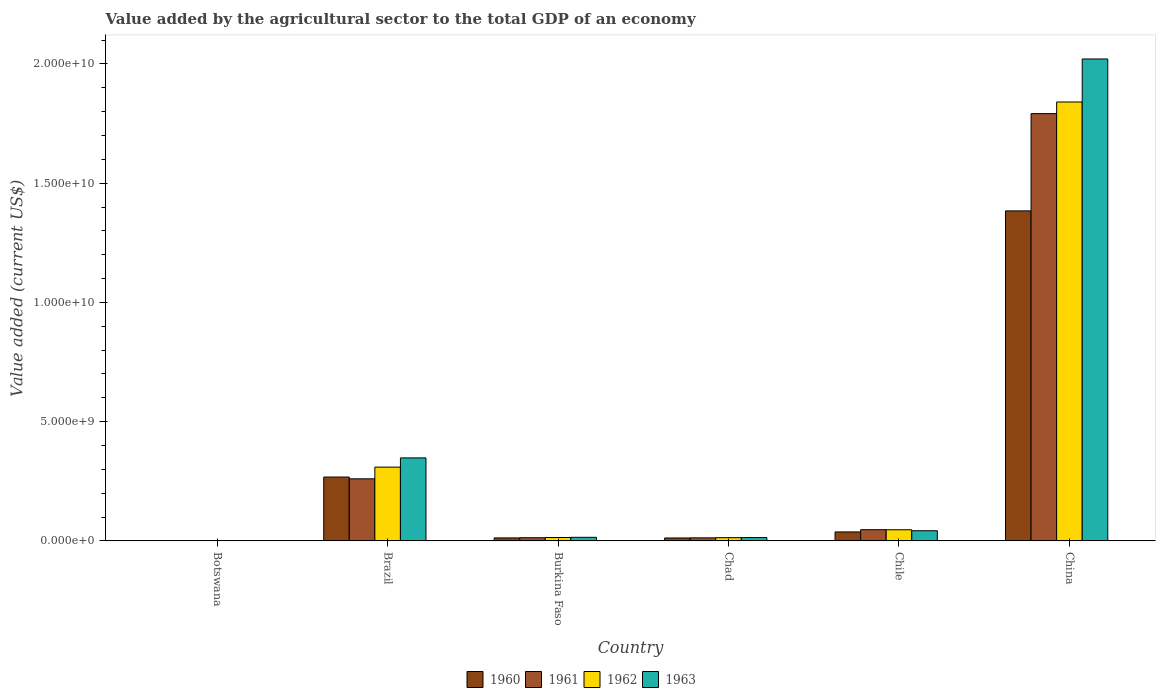How many bars are there on the 2nd tick from the left?
Provide a succinct answer. 4. How many bars are there on the 6th tick from the right?
Provide a succinct answer. 4. What is the label of the 3rd group of bars from the left?
Provide a short and direct response. Burkina Faso. What is the value added by the agricultural sector to the total GDP in 1963 in China?
Your response must be concise. 2.02e+1. Across all countries, what is the maximum value added by the agricultural sector to the total GDP in 1962?
Keep it short and to the point. 1.84e+1. Across all countries, what is the minimum value added by the agricultural sector to the total GDP in 1961?
Make the answer very short. 1.38e+07. In which country was the value added by the agricultural sector to the total GDP in 1962 maximum?
Your answer should be very brief. China. In which country was the value added by the agricultural sector to the total GDP in 1961 minimum?
Give a very brief answer. Botswana. What is the total value added by the agricultural sector to the total GDP in 1963 in the graph?
Provide a succinct answer. 2.44e+1. What is the difference between the value added by the agricultural sector to the total GDP in 1960 in Botswana and that in Burkina Faso?
Give a very brief answer. -1.14e+08. What is the difference between the value added by the agricultural sector to the total GDP in 1962 in Burkina Faso and the value added by the agricultural sector to the total GDP in 1963 in Chad?
Make the answer very short. 2.33e+06. What is the average value added by the agricultural sector to the total GDP in 1961 per country?
Give a very brief answer. 3.55e+09. What is the difference between the value added by the agricultural sector to the total GDP of/in 1962 and value added by the agricultural sector to the total GDP of/in 1960 in Brazil?
Offer a terse response. 4.16e+08. What is the ratio of the value added by the agricultural sector to the total GDP in 1963 in Botswana to that in China?
Your answer should be compact. 0. Is the value added by the agricultural sector to the total GDP in 1962 in Botswana less than that in Chad?
Your answer should be compact. Yes. What is the difference between the highest and the second highest value added by the agricultural sector to the total GDP in 1963?
Your answer should be very brief. 1.98e+1. What is the difference between the highest and the lowest value added by the agricultural sector to the total GDP in 1963?
Provide a succinct answer. 2.02e+1. Is it the case that in every country, the sum of the value added by the agricultural sector to the total GDP in 1962 and value added by the agricultural sector to the total GDP in 1960 is greater than the sum of value added by the agricultural sector to the total GDP in 1963 and value added by the agricultural sector to the total GDP in 1961?
Provide a succinct answer. No. What does the 1st bar from the right in Botswana represents?
Your response must be concise. 1963. How many bars are there?
Give a very brief answer. 24. How many countries are there in the graph?
Provide a succinct answer. 6. What is the difference between two consecutive major ticks on the Y-axis?
Make the answer very short. 5.00e+09. Does the graph contain grids?
Provide a succinct answer. No. Where does the legend appear in the graph?
Your response must be concise. Bottom center. What is the title of the graph?
Keep it short and to the point. Value added by the agricultural sector to the total GDP of an economy. Does "1971" appear as one of the legend labels in the graph?
Give a very brief answer. No. What is the label or title of the Y-axis?
Offer a very short reply. Value added (current US$). What is the Value added (current US$) of 1960 in Botswana?
Your answer should be very brief. 1.31e+07. What is the Value added (current US$) in 1961 in Botswana?
Keep it short and to the point. 1.38e+07. What is the Value added (current US$) of 1962 in Botswana?
Give a very brief answer. 1.45e+07. What is the Value added (current US$) in 1963 in Botswana?
Provide a succinct answer. 1.51e+07. What is the Value added (current US$) of 1960 in Brazil?
Your answer should be very brief. 2.68e+09. What is the Value added (current US$) in 1961 in Brazil?
Offer a very short reply. 2.60e+09. What is the Value added (current US$) in 1962 in Brazil?
Offer a very short reply. 3.10e+09. What is the Value added (current US$) in 1963 in Brazil?
Your answer should be compact. 3.48e+09. What is the Value added (current US$) in 1960 in Burkina Faso?
Provide a short and direct response. 1.27e+08. What is the Value added (current US$) in 1961 in Burkina Faso?
Offer a terse response. 1.34e+08. What is the Value added (current US$) of 1962 in Burkina Faso?
Your response must be concise. 1.44e+08. What is the Value added (current US$) in 1963 in Burkina Faso?
Provide a short and direct response. 1.52e+08. What is the Value added (current US$) in 1960 in Chad?
Offer a very short reply. 1.25e+08. What is the Value added (current US$) in 1961 in Chad?
Keep it short and to the point. 1.29e+08. What is the Value added (current US$) in 1962 in Chad?
Offer a terse response. 1.38e+08. What is the Value added (current US$) of 1963 in Chad?
Provide a succinct answer. 1.41e+08. What is the Value added (current US$) of 1960 in Chile?
Give a very brief answer. 3.78e+08. What is the Value added (current US$) of 1961 in Chile?
Provide a short and direct response. 4.72e+08. What is the Value added (current US$) in 1962 in Chile?
Your response must be concise. 4.69e+08. What is the Value added (current US$) of 1963 in Chile?
Give a very brief answer. 4.28e+08. What is the Value added (current US$) of 1960 in China?
Your response must be concise. 1.38e+1. What is the Value added (current US$) of 1961 in China?
Your answer should be compact. 1.79e+1. What is the Value added (current US$) in 1962 in China?
Make the answer very short. 1.84e+1. What is the Value added (current US$) of 1963 in China?
Make the answer very short. 2.02e+1. Across all countries, what is the maximum Value added (current US$) of 1960?
Your response must be concise. 1.38e+1. Across all countries, what is the maximum Value added (current US$) of 1961?
Provide a short and direct response. 1.79e+1. Across all countries, what is the maximum Value added (current US$) of 1962?
Keep it short and to the point. 1.84e+1. Across all countries, what is the maximum Value added (current US$) of 1963?
Your answer should be very brief. 2.02e+1. Across all countries, what is the minimum Value added (current US$) in 1960?
Make the answer very short. 1.31e+07. Across all countries, what is the minimum Value added (current US$) in 1961?
Give a very brief answer. 1.38e+07. Across all countries, what is the minimum Value added (current US$) in 1962?
Make the answer very short. 1.45e+07. Across all countries, what is the minimum Value added (current US$) of 1963?
Your response must be concise. 1.51e+07. What is the total Value added (current US$) in 1960 in the graph?
Ensure brevity in your answer.  1.72e+1. What is the total Value added (current US$) in 1961 in the graph?
Offer a very short reply. 2.13e+1. What is the total Value added (current US$) of 1962 in the graph?
Provide a succinct answer. 2.23e+1. What is the total Value added (current US$) in 1963 in the graph?
Your response must be concise. 2.44e+1. What is the difference between the Value added (current US$) of 1960 in Botswana and that in Brazil?
Your answer should be compact. -2.67e+09. What is the difference between the Value added (current US$) of 1961 in Botswana and that in Brazil?
Offer a terse response. -2.59e+09. What is the difference between the Value added (current US$) of 1962 in Botswana and that in Brazil?
Ensure brevity in your answer.  -3.08e+09. What is the difference between the Value added (current US$) in 1963 in Botswana and that in Brazil?
Your answer should be compact. -3.47e+09. What is the difference between the Value added (current US$) of 1960 in Botswana and that in Burkina Faso?
Offer a very short reply. -1.14e+08. What is the difference between the Value added (current US$) in 1961 in Botswana and that in Burkina Faso?
Your response must be concise. -1.20e+08. What is the difference between the Value added (current US$) in 1962 in Botswana and that in Burkina Faso?
Your response must be concise. -1.29e+08. What is the difference between the Value added (current US$) in 1963 in Botswana and that in Burkina Faso?
Provide a short and direct response. -1.37e+08. What is the difference between the Value added (current US$) of 1960 in Botswana and that in Chad?
Give a very brief answer. -1.11e+08. What is the difference between the Value added (current US$) in 1961 in Botswana and that in Chad?
Offer a terse response. -1.16e+08. What is the difference between the Value added (current US$) in 1962 in Botswana and that in Chad?
Make the answer very short. -1.23e+08. What is the difference between the Value added (current US$) in 1963 in Botswana and that in Chad?
Give a very brief answer. -1.26e+08. What is the difference between the Value added (current US$) of 1960 in Botswana and that in Chile?
Offer a very short reply. -3.65e+08. What is the difference between the Value added (current US$) in 1961 in Botswana and that in Chile?
Provide a succinct answer. -4.58e+08. What is the difference between the Value added (current US$) in 1962 in Botswana and that in Chile?
Offer a terse response. -4.54e+08. What is the difference between the Value added (current US$) in 1963 in Botswana and that in Chile?
Your answer should be compact. -4.13e+08. What is the difference between the Value added (current US$) in 1960 in Botswana and that in China?
Offer a terse response. -1.38e+1. What is the difference between the Value added (current US$) in 1961 in Botswana and that in China?
Make the answer very short. -1.79e+1. What is the difference between the Value added (current US$) of 1962 in Botswana and that in China?
Offer a very short reply. -1.84e+1. What is the difference between the Value added (current US$) of 1963 in Botswana and that in China?
Provide a short and direct response. -2.02e+1. What is the difference between the Value added (current US$) of 1960 in Brazil and that in Burkina Faso?
Make the answer very short. 2.55e+09. What is the difference between the Value added (current US$) in 1961 in Brazil and that in Burkina Faso?
Provide a short and direct response. 2.47e+09. What is the difference between the Value added (current US$) in 1962 in Brazil and that in Burkina Faso?
Provide a short and direct response. 2.95e+09. What is the difference between the Value added (current US$) in 1963 in Brazil and that in Burkina Faso?
Your response must be concise. 3.33e+09. What is the difference between the Value added (current US$) of 1960 in Brazil and that in Chad?
Ensure brevity in your answer.  2.55e+09. What is the difference between the Value added (current US$) of 1961 in Brazil and that in Chad?
Make the answer very short. 2.48e+09. What is the difference between the Value added (current US$) of 1962 in Brazil and that in Chad?
Offer a very short reply. 2.96e+09. What is the difference between the Value added (current US$) of 1963 in Brazil and that in Chad?
Ensure brevity in your answer.  3.34e+09. What is the difference between the Value added (current US$) of 1960 in Brazil and that in Chile?
Ensure brevity in your answer.  2.30e+09. What is the difference between the Value added (current US$) in 1961 in Brazil and that in Chile?
Provide a succinct answer. 2.13e+09. What is the difference between the Value added (current US$) in 1962 in Brazil and that in Chile?
Provide a short and direct response. 2.63e+09. What is the difference between the Value added (current US$) in 1963 in Brazil and that in Chile?
Your answer should be very brief. 3.05e+09. What is the difference between the Value added (current US$) of 1960 in Brazil and that in China?
Provide a short and direct response. -1.12e+1. What is the difference between the Value added (current US$) of 1961 in Brazil and that in China?
Offer a terse response. -1.53e+1. What is the difference between the Value added (current US$) of 1962 in Brazil and that in China?
Keep it short and to the point. -1.53e+1. What is the difference between the Value added (current US$) of 1963 in Brazil and that in China?
Provide a succinct answer. -1.67e+1. What is the difference between the Value added (current US$) in 1960 in Burkina Faso and that in Chad?
Your response must be concise. 2.61e+06. What is the difference between the Value added (current US$) of 1961 in Burkina Faso and that in Chad?
Ensure brevity in your answer.  4.79e+06. What is the difference between the Value added (current US$) in 1962 in Burkina Faso and that in Chad?
Ensure brevity in your answer.  6.10e+06. What is the difference between the Value added (current US$) in 1963 in Burkina Faso and that in Chad?
Ensure brevity in your answer.  1.03e+07. What is the difference between the Value added (current US$) of 1960 in Burkina Faso and that in Chile?
Your answer should be compact. -2.51e+08. What is the difference between the Value added (current US$) in 1961 in Burkina Faso and that in Chile?
Your answer should be compact. -3.38e+08. What is the difference between the Value added (current US$) in 1962 in Burkina Faso and that in Chile?
Ensure brevity in your answer.  -3.25e+08. What is the difference between the Value added (current US$) of 1963 in Burkina Faso and that in Chile?
Provide a short and direct response. -2.76e+08. What is the difference between the Value added (current US$) of 1960 in Burkina Faso and that in China?
Give a very brief answer. -1.37e+1. What is the difference between the Value added (current US$) of 1961 in Burkina Faso and that in China?
Offer a very short reply. -1.78e+1. What is the difference between the Value added (current US$) of 1962 in Burkina Faso and that in China?
Offer a very short reply. -1.83e+1. What is the difference between the Value added (current US$) in 1963 in Burkina Faso and that in China?
Provide a succinct answer. -2.01e+1. What is the difference between the Value added (current US$) in 1960 in Chad and that in Chile?
Your answer should be compact. -2.54e+08. What is the difference between the Value added (current US$) of 1961 in Chad and that in Chile?
Provide a short and direct response. -3.43e+08. What is the difference between the Value added (current US$) of 1962 in Chad and that in Chile?
Your answer should be compact. -3.31e+08. What is the difference between the Value added (current US$) in 1963 in Chad and that in Chile?
Your answer should be compact. -2.87e+08. What is the difference between the Value added (current US$) in 1960 in Chad and that in China?
Offer a terse response. -1.37e+1. What is the difference between the Value added (current US$) in 1961 in Chad and that in China?
Your answer should be very brief. -1.78e+1. What is the difference between the Value added (current US$) of 1962 in Chad and that in China?
Your answer should be compact. -1.83e+1. What is the difference between the Value added (current US$) of 1963 in Chad and that in China?
Your answer should be compact. -2.01e+1. What is the difference between the Value added (current US$) of 1960 in Chile and that in China?
Make the answer very short. -1.35e+1. What is the difference between the Value added (current US$) of 1961 in Chile and that in China?
Offer a terse response. -1.74e+1. What is the difference between the Value added (current US$) in 1962 in Chile and that in China?
Offer a very short reply. -1.79e+1. What is the difference between the Value added (current US$) in 1963 in Chile and that in China?
Your answer should be compact. -1.98e+1. What is the difference between the Value added (current US$) of 1960 in Botswana and the Value added (current US$) of 1961 in Brazil?
Ensure brevity in your answer.  -2.59e+09. What is the difference between the Value added (current US$) of 1960 in Botswana and the Value added (current US$) of 1962 in Brazil?
Offer a very short reply. -3.08e+09. What is the difference between the Value added (current US$) of 1960 in Botswana and the Value added (current US$) of 1963 in Brazil?
Offer a terse response. -3.47e+09. What is the difference between the Value added (current US$) of 1961 in Botswana and the Value added (current US$) of 1962 in Brazil?
Your answer should be compact. -3.08e+09. What is the difference between the Value added (current US$) of 1961 in Botswana and the Value added (current US$) of 1963 in Brazil?
Give a very brief answer. -3.47e+09. What is the difference between the Value added (current US$) in 1962 in Botswana and the Value added (current US$) in 1963 in Brazil?
Provide a succinct answer. -3.47e+09. What is the difference between the Value added (current US$) in 1960 in Botswana and the Value added (current US$) in 1961 in Burkina Faso?
Ensure brevity in your answer.  -1.21e+08. What is the difference between the Value added (current US$) of 1960 in Botswana and the Value added (current US$) of 1962 in Burkina Faso?
Provide a short and direct response. -1.31e+08. What is the difference between the Value added (current US$) of 1960 in Botswana and the Value added (current US$) of 1963 in Burkina Faso?
Provide a succinct answer. -1.39e+08. What is the difference between the Value added (current US$) in 1961 in Botswana and the Value added (current US$) in 1962 in Burkina Faso?
Provide a succinct answer. -1.30e+08. What is the difference between the Value added (current US$) of 1961 in Botswana and the Value added (current US$) of 1963 in Burkina Faso?
Offer a very short reply. -1.38e+08. What is the difference between the Value added (current US$) of 1962 in Botswana and the Value added (current US$) of 1963 in Burkina Faso?
Your response must be concise. -1.37e+08. What is the difference between the Value added (current US$) in 1960 in Botswana and the Value added (current US$) in 1961 in Chad?
Make the answer very short. -1.16e+08. What is the difference between the Value added (current US$) of 1960 in Botswana and the Value added (current US$) of 1962 in Chad?
Offer a very short reply. -1.24e+08. What is the difference between the Value added (current US$) in 1960 in Botswana and the Value added (current US$) in 1963 in Chad?
Offer a very short reply. -1.28e+08. What is the difference between the Value added (current US$) of 1961 in Botswana and the Value added (current US$) of 1962 in Chad?
Offer a terse response. -1.24e+08. What is the difference between the Value added (current US$) in 1961 in Botswana and the Value added (current US$) in 1963 in Chad?
Your response must be concise. -1.28e+08. What is the difference between the Value added (current US$) of 1962 in Botswana and the Value added (current US$) of 1963 in Chad?
Make the answer very short. -1.27e+08. What is the difference between the Value added (current US$) of 1960 in Botswana and the Value added (current US$) of 1961 in Chile?
Your response must be concise. -4.59e+08. What is the difference between the Value added (current US$) in 1960 in Botswana and the Value added (current US$) in 1962 in Chile?
Offer a very short reply. -4.55e+08. What is the difference between the Value added (current US$) of 1960 in Botswana and the Value added (current US$) of 1963 in Chile?
Offer a terse response. -4.15e+08. What is the difference between the Value added (current US$) of 1961 in Botswana and the Value added (current US$) of 1962 in Chile?
Provide a succinct answer. -4.55e+08. What is the difference between the Value added (current US$) of 1961 in Botswana and the Value added (current US$) of 1963 in Chile?
Your answer should be very brief. -4.14e+08. What is the difference between the Value added (current US$) in 1962 in Botswana and the Value added (current US$) in 1963 in Chile?
Make the answer very short. -4.13e+08. What is the difference between the Value added (current US$) in 1960 in Botswana and the Value added (current US$) in 1961 in China?
Provide a short and direct response. -1.79e+1. What is the difference between the Value added (current US$) of 1960 in Botswana and the Value added (current US$) of 1962 in China?
Offer a terse response. -1.84e+1. What is the difference between the Value added (current US$) in 1960 in Botswana and the Value added (current US$) in 1963 in China?
Make the answer very short. -2.02e+1. What is the difference between the Value added (current US$) of 1961 in Botswana and the Value added (current US$) of 1962 in China?
Offer a terse response. -1.84e+1. What is the difference between the Value added (current US$) of 1961 in Botswana and the Value added (current US$) of 1963 in China?
Provide a short and direct response. -2.02e+1. What is the difference between the Value added (current US$) in 1962 in Botswana and the Value added (current US$) in 1963 in China?
Your answer should be very brief. -2.02e+1. What is the difference between the Value added (current US$) in 1960 in Brazil and the Value added (current US$) in 1961 in Burkina Faso?
Offer a very short reply. 2.55e+09. What is the difference between the Value added (current US$) of 1960 in Brazil and the Value added (current US$) of 1962 in Burkina Faso?
Give a very brief answer. 2.54e+09. What is the difference between the Value added (current US$) of 1960 in Brazil and the Value added (current US$) of 1963 in Burkina Faso?
Give a very brief answer. 2.53e+09. What is the difference between the Value added (current US$) of 1961 in Brazil and the Value added (current US$) of 1962 in Burkina Faso?
Make the answer very short. 2.46e+09. What is the difference between the Value added (current US$) of 1961 in Brazil and the Value added (current US$) of 1963 in Burkina Faso?
Provide a succinct answer. 2.45e+09. What is the difference between the Value added (current US$) of 1962 in Brazil and the Value added (current US$) of 1963 in Burkina Faso?
Make the answer very short. 2.94e+09. What is the difference between the Value added (current US$) of 1960 in Brazil and the Value added (current US$) of 1961 in Chad?
Offer a terse response. 2.55e+09. What is the difference between the Value added (current US$) of 1960 in Brazil and the Value added (current US$) of 1962 in Chad?
Give a very brief answer. 2.54e+09. What is the difference between the Value added (current US$) of 1960 in Brazil and the Value added (current US$) of 1963 in Chad?
Ensure brevity in your answer.  2.54e+09. What is the difference between the Value added (current US$) of 1961 in Brazil and the Value added (current US$) of 1962 in Chad?
Offer a very short reply. 2.47e+09. What is the difference between the Value added (current US$) in 1961 in Brazil and the Value added (current US$) in 1963 in Chad?
Make the answer very short. 2.46e+09. What is the difference between the Value added (current US$) in 1962 in Brazil and the Value added (current US$) in 1963 in Chad?
Your response must be concise. 2.95e+09. What is the difference between the Value added (current US$) in 1960 in Brazil and the Value added (current US$) in 1961 in Chile?
Your answer should be very brief. 2.21e+09. What is the difference between the Value added (current US$) in 1960 in Brazil and the Value added (current US$) in 1962 in Chile?
Make the answer very short. 2.21e+09. What is the difference between the Value added (current US$) in 1960 in Brazil and the Value added (current US$) in 1963 in Chile?
Give a very brief answer. 2.25e+09. What is the difference between the Value added (current US$) in 1961 in Brazil and the Value added (current US$) in 1962 in Chile?
Your answer should be very brief. 2.14e+09. What is the difference between the Value added (current US$) in 1961 in Brazil and the Value added (current US$) in 1963 in Chile?
Offer a very short reply. 2.18e+09. What is the difference between the Value added (current US$) of 1962 in Brazil and the Value added (current US$) of 1963 in Chile?
Your response must be concise. 2.67e+09. What is the difference between the Value added (current US$) of 1960 in Brazil and the Value added (current US$) of 1961 in China?
Make the answer very short. -1.52e+1. What is the difference between the Value added (current US$) of 1960 in Brazil and the Value added (current US$) of 1962 in China?
Your response must be concise. -1.57e+1. What is the difference between the Value added (current US$) in 1960 in Brazil and the Value added (current US$) in 1963 in China?
Your answer should be very brief. -1.75e+1. What is the difference between the Value added (current US$) of 1961 in Brazil and the Value added (current US$) of 1962 in China?
Your response must be concise. -1.58e+1. What is the difference between the Value added (current US$) of 1961 in Brazil and the Value added (current US$) of 1963 in China?
Give a very brief answer. -1.76e+1. What is the difference between the Value added (current US$) of 1962 in Brazil and the Value added (current US$) of 1963 in China?
Offer a terse response. -1.71e+1. What is the difference between the Value added (current US$) in 1960 in Burkina Faso and the Value added (current US$) in 1961 in Chad?
Your answer should be very brief. -2.21e+06. What is the difference between the Value added (current US$) in 1960 in Burkina Faso and the Value added (current US$) in 1962 in Chad?
Provide a succinct answer. -1.04e+07. What is the difference between the Value added (current US$) of 1960 in Burkina Faso and the Value added (current US$) of 1963 in Chad?
Your response must be concise. -1.42e+07. What is the difference between the Value added (current US$) in 1961 in Burkina Faso and the Value added (current US$) in 1962 in Chad?
Make the answer very short. -3.43e+06. What is the difference between the Value added (current US$) of 1961 in Burkina Faso and the Value added (current US$) of 1963 in Chad?
Give a very brief answer. -7.20e+06. What is the difference between the Value added (current US$) in 1962 in Burkina Faso and the Value added (current US$) in 1963 in Chad?
Your response must be concise. 2.33e+06. What is the difference between the Value added (current US$) in 1960 in Burkina Faso and the Value added (current US$) in 1961 in Chile?
Offer a terse response. -3.45e+08. What is the difference between the Value added (current US$) in 1960 in Burkina Faso and the Value added (current US$) in 1962 in Chile?
Offer a terse response. -3.41e+08. What is the difference between the Value added (current US$) in 1960 in Burkina Faso and the Value added (current US$) in 1963 in Chile?
Ensure brevity in your answer.  -3.01e+08. What is the difference between the Value added (current US$) in 1961 in Burkina Faso and the Value added (current US$) in 1962 in Chile?
Your response must be concise. -3.34e+08. What is the difference between the Value added (current US$) of 1961 in Burkina Faso and the Value added (current US$) of 1963 in Chile?
Your answer should be compact. -2.94e+08. What is the difference between the Value added (current US$) in 1962 in Burkina Faso and the Value added (current US$) in 1963 in Chile?
Offer a terse response. -2.84e+08. What is the difference between the Value added (current US$) in 1960 in Burkina Faso and the Value added (current US$) in 1961 in China?
Offer a very short reply. -1.78e+1. What is the difference between the Value added (current US$) of 1960 in Burkina Faso and the Value added (current US$) of 1962 in China?
Keep it short and to the point. -1.83e+1. What is the difference between the Value added (current US$) in 1960 in Burkina Faso and the Value added (current US$) in 1963 in China?
Provide a succinct answer. -2.01e+1. What is the difference between the Value added (current US$) of 1961 in Burkina Faso and the Value added (current US$) of 1962 in China?
Your answer should be compact. -1.83e+1. What is the difference between the Value added (current US$) of 1961 in Burkina Faso and the Value added (current US$) of 1963 in China?
Provide a short and direct response. -2.01e+1. What is the difference between the Value added (current US$) of 1962 in Burkina Faso and the Value added (current US$) of 1963 in China?
Give a very brief answer. -2.01e+1. What is the difference between the Value added (current US$) of 1960 in Chad and the Value added (current US$) of 1961 in Chile?
Provide a short and direct response. -3.48e+08. What is the difference between the Value added (current US$) in 1960 in Chad and the Value added (current US$) in 1962 in Chile?
Keep it short and to the point. -3.44e+08. What is the difference between the Value added (current US$) in 1960 in Chad and the Value added (current US$) in 1963 in Chile?
Your response must be concise. -3.03e+08. What is the difference between the Value added (current US$) in 1961 in Chad and the Value added (current US$) in 1962 in Chile?
Ensure brevity in your answer.  -3.39e+08. What is the difference between the Value added (current US$) of 1961 in Chad and the Value added (current US$) of 1963 in Chile?
Your response must be concise. -2.99e+08. What is the difference between the Value added (current US$) in 1962 in Chad and the Value added (current US$) in 1963 in Chile?
Provide a succinct answer. -2.90e+08. What is the difference between the Value added (current US$) of 1960 in Chad and the Value added (current US$) of 1961 in China?
Make the answer very short. -1.78e+1. What is the difference between the Value added (current US$) of 1960 in Chad and the Value added (current US$) of 1962 in China?
Your response must be concise. -1.83e+1. What is the difference between the Value added (current US$) in 1960 in Chad and the Value added (current US$) in 1963 in China?
Give a very brief answer. -2.01e+1. What is the difference between the Value added (current US$) of 1961 in Chad and the Value added (current US$) of 1962 in China?
Provide a short and direct response. -1.83e+1. What is the difference between the Value added (current US$) in 1961 in Chad and the Value added (current US$) in 1963 in China?
Provide a succinct answer. -2.01e+1. What is the difference between the Value added (current US$) in 1962 in Chad and the Value added (current US$) in 1963 in China?
Offer a very short reply. -2.01e+1. What is the difference between the Value added (current US$) in 1960 in Chile and the Value added (current US$) in 1961 in China?
Your answer should be compact. -1.75e+1. What is the difference between the Value added (current US$) of 1960 in Chile and the Value added (current US$) of 1962 in China?
Make the answer very short. -1.80e+1. What is the difference between the Value added (current US$) of 1960 in Chile and the Value added (current US$) of 1963 in China?
Your response must be concise. -1.98e+1. What is the difference between the Value added (current US$) of 1961 in Chile and the Value added (current US$) of 1962 in China?
Keep it short and to the point. -1.79e+1. What is the difference between the Value added (current US$) of 1961 in Chile and the Value added (current US$) of 1963 in China?
Offer a very short reply. -1.97e+1. What is the difference between the Value added (current US$) of 1962 in Chile and the Value added (current US$) of 1963 in China?
Give a very brief answer. -1.97e+1. What is the average Value added (current US$) of 1960 per country?
Keep it short and to the point. 2.86e+09. What is the average Value added (current US$) in 1961 per country?
Your response must be concise. 3.55e+09. What is the average Value added (current US$) in 1962 per country?
Offer a terse response. 3.71e+09. What is the average Value added (current US$) in 1963 per country?
Your response must be concise. 4.07e+09. What is the difference between the Value added (current US$) of 1960 and Value added (current US$) of 1961 in Botswana?
Ensure brevity in your answer.  -6.50e+05. What is the difference between the Value added (current US$) of 1960 and Value added (current US$) of 1962 in Botswana?
Offer a terse response. -1.35e+06. What is the difference between the Value added (current US$) in 1960 and Value added (current US$) in 1963 in Botswana?
Give a very brief answer. -1.99e+06. What is the difference between the Value added (current US$) in 1961 and Value added (current US$) in 1962 in Botswana?
Keep it short and to the point. -7.04e+05. What is the difference between the Value added (current US$) in 1961 and Value added (current US$) in 1963 in Botswana?
Keep it short and to the point. -1.34e+06. What is the difference between the Value added (current US$) in 1962 and Value added (current US$) in 1963 in Botswana?
Ensure brevity in your answer.  -6.34e+05. What is the difference between the Value added (current US$) in 1960 and Value added (current US$) in 1961 in Brazil?
Offer a very short reply. 7.45e+07. What is the difference between the Value added (current US$) in 1960 and Value added (current US$) in 1962 in Brazil?
Offer a terse response. -4.16e+08. What is the difference between the Value added (current US$) of 1960 and Value added (current US$) of 1963 in Brazil?
Make the answer very short. -8.03e+08. What is the difference between the Value added (current US$) in 1961 and Value added (current US$) in 1962 in Brazil?
Ensure brevity in your answer.  -4.91e+08. What is the difference between the Value added (current US$) in 1961 and Value added (current US$) in 1963 in Brazil?
Make the answer very short. -8.77e+08. What is the difference between the Value added (current US$) of 1962 and Value added (current US$) of 1963 in Brazil?
Make the answer very short. -3.87e+08. What is the difference between the Value added (current US$) in 1960 and Value added (current US$) in 1961 in Burkina Faso?
Your answer should be compact. -7.00e+06. What is the difference between the Value added (current US$) in 1960 and Value added (current US$) in 1962 in Burkina Faso?
Your answer should be very brief. -1.65e+07. What is the difference between the Value added (current US$) of 1960 and Value added (current US$) of 1963 in Burkina Faso?
Provide a succinct answer. -2.45e+07. What is the difference between the Value added (current US$) in 1961 and Value added (current US$) in 1962 in Burkina Faso?
Your answer should be very brief. -9.53e+06. What is the difference between the Value added (current US$) in 1961 and Value added (current US$) in 1963 in Burkina Faso?
Your answer should be very brief. -1.75e+07. What is the difference between the Value added (current US$) in 1962 and Value added (current US$) in 1963 in Burkina Faso?
Your answer should be compact. -7.98e+06. What is the difference between the Value added (current US$) of 1960 and Value added (current US$) of 1961 in Chad?
Keep it short and to the point. -4.82e+06. What is the difference between the Value added (current US$) in 1960 and Value added (current US$) in 1962 in Chad?
Keep it short and to the point. -1.30e+07. What is the difference between the Value added (current US$) in 1960 and Value added (current US$) in 1963 in Chad?
Ensure brevity in your answer.  -1.68e+07. What is the difference between the Value added (current US$) of 1961 and Value added (current US$) of 1962 in Chad?
Provide a succinct answer. -8.22e+06. What is the difference between the Value added (current US$) of 1961 and Value added (current US$) of 1963 in Chad?
Offer a very short reply. -1.20e+07. What is the difference between the Value added (current US$) of 1962 and Value added (current US$) of 1963 in Chad?
Provide a succinct answer. -3.78e+06. What is the difference between the Value added (current US$) of 1960 and Value added (current US$) of 1961 in Chile?
Offer a terse response. -9.41e+07. What is the difference between the Value added (current US$) of 1960 and Value added (current US$) of 1962 in Chile?
Your response must be concise. -9.05e+07. What is the difference between the Value added (current US$) in 1960 and Value added (current US$) in 1963 in Chile?
Provide a short and direct response. -4.98e+07. What is the difference between the Value added (current US$) of 1961 and Value added (current US$) of 1962 in Chile?
Make the answer very short. 3.57e+06. What is the difference between the Value added (current US$) of 1961 and Value added (current US$) of 1963 in Chile?
Offer a very short reply. 4.42e+07. What is the difference between the Value added (current US$) in 1962 and Value added (current US$) in 1963 in Chile?
Ensure brevity in your answer.  4.07e+07. What is the difference between the Value added (current US$) of 1960 and Value added (current US$) of 1961 in China?
Your answer should be very brief. -4.08e+09. What is the difference between the Value added (current US$) of 1960 and Value added (current US$) of 1962 in China?
Your response must be concise. -4.57e+09. What is the difference between the Value added (current US$) of 1960 and Value added (current US$) of 1963 in China?
Your answer should be very brief. -6.37e+09. What is the difference between the Value added (current US$) in 1961 and Value added (current US$) in 1962 in China?
Provide a short and direct response. -4.87e+08. What is the difference between the Value added (current US$) in 1961 and Value added (current US$) in 1963 in China?
Provide a succinct answer. -2.29e+09. What is the difference between the Value added (current US$) in 1962 and Value added (current US$) in 1963 in China?
Your answer should be compact. -1.80e+09. What is the ratio of the Value added (current US$) of 1960 in Botswana to that in Brazil?
Ensure brevity in your answer.  0. What is the ratio of the Value added (current US$) in 1961 in Botswana to that in Brazil?
Offer a very short reply. 0.01. What is the ratio of the Value added (current US$) of 1962 in Botswana to that in Brazil?
Offer a very short reply. 0. What is the ratio of the Value added (current US$) in 1963 in Botswana to that in Brazil?
Offer a very short reply. 0. What is the ratio of the Value added (current US$) of 1960 in Botswana to that in Burkina Faso?
Make the answer very short. 0.1. What is the ratio of the Value added (current US$) of 1961 in Botswana to that in Burkina Faso?
Your answer should be compact. 0.1. What is the ratio of the Value added (current US$) in 1962 in Botswana to that in Burkina Faso?
Ensure brevity in your answer.  0.1. What is the ratio of the Value added (current US$) in 1963 in Botswana to that in Burkina Faso?
Your answer should be very brief. 0.1. What is the ratio of the Value added (current US$) of 1960 in Botswana to that in Chad?
Offer a terse response. 0.11. What is the ratio of the Value added (current US$) in 1961 in Botswana to that in Chad?
Offer a terse response. 0.11. What is the ratio of the Value added (current US$) in 1962 in Botswana to that in Chad?
Keep it short and to the point. 0.11. What is the ratio of the Value added (current US$) of 1963 in Botswana to that in Chad?
Offer a terse response. 0.11. What is the ratio of the Value added (current US$) of 1960 in Botswana to that in Chile?
Your answer should be compact. 0.03. What is the ratio of the Value added (current US$) of 1961 in Botswana to that in Chile?
Provide a short and direct response. 0.03. What is the ratio of the Value added (current US$) of 1962 in Botswana to that in Chile?
Your answer should be very brief. 0.03. What is the ratio of the Value added (current US$) in 1963 in Botswana to that in Chile?
Ensure brevity in your answer.  0.04. What is the ratio of the Value added (current US$) in 1960 in Botswana to that in China?
Give a very brief answer. 0. What is the ratio of the Value added (current US$) in 1961 in Botswana to that in China?
Offer a very short reply. 0. What is the ratio of the Value added (current US$) of 1962 in Botswana to that in China?
Provide a short and direct response. 0. What is the ratio of the Value added (current US$) of 1963 in Botswana to that in China?
Your answer should be very brief. 0. What is the ratio of the Value added (current US$) of 1960 in Brazil to that in Burkina Faso?
Provide a succinct answer. 21.07. What is the ratio of the Value added (current US$) of 1961 in Brazil to that in Burkina Faso?
Your response must be concise. 19.41. What is the ratio of the Value added (current US$) of 1962 in Brazil to that in Burkina Faso?
Provide a short and direct response. 21.54. What is the ratio of the Value added (current US$) of 1963 in Brazil to that in Burkina Faso?
Offer a very short reply. 22.96. What is the ratio of the Value added (current US$) of 1960 in Brazil to that in Chad?
Your response must be concise. 21.51. What is the ratio of the Value added (current US$) of 1961 in Brazil to that in Chad?
Ensure brevity in your answer.  20.13. What is the ratio of the Value added (current US$) in 1962 in Brazil to that in Chad?
Offer a terse response. 22.5. What is the ratio of the Value added (current US$) in 1963 in Brazil to that in Chad?
Offer a very short reply. 24.63. What is the ratio of the Value added (current US$) of 1960 in Brazil to that in Chile?
Keep it short and to the point. 7.09. What is the ratio of the Value added (current US$) of 1961 in Brazil to that in Chile?
Make the answer very short. 5.52. What is the ratio of the Value added (current US$) in 1962 in Brazil to that in Chile?
Offer a very short reply. 6.61. What is the ratio of the Value added (current US$) in 1963 in Brazil to that in Chile?
Your response must be concise. 8.14. What is the ratio of the Value added (current US$) of 1960 in Brazil to that in China?
Your answer should be compact. 0.19. What is the ratio of the Value added (current US$) of 1961 in Brazil to that in China?
Give a very brief answer. 0.15. What is the ratio of the Value added (current US$) of 1962 in Brazil to that in China?
Your answer should be very brief. 0.17. What is the ratio of the Value added (current US$) in 1963 in Brazil to that in China?
Your response must be concise. 0.17. What is the ratio of the Value added (current US$) of 1960 in Burkina Faso to that in Chad?
Give a very brief answer. 1.02. What is the ratio of the Value added (current US$) of 1961 in Burkina Faso to that in Chad?
Keep it short and to the point. 1.04. What is the ratio of the Value added (current US$) of 1962 in Burkina Faso to that in Chad?
Your response must be concise. 1.04. What is the ratio of the Value added (current US$) of 1963 in Burkina Faso to that in Chad?
Your answer should be compact. 1.07. What is the ratio of the Value added (current US$) in 1960 in Burkina Faso to that in Chile?
Your answer should be very brief. 0.34. What is the ratio of the Value added (current US$) in 1961 in Burkina Faso to that in Chile?
Ensure brevity in your answer.  0.28. What is the ratio of the Value added (current US$) in 1962 in Burkina Faso to that in Chile?
Your answer should be very brief. 0.31. What is the ratio of the Value added (current US$) in 1963 in Burkina Faso to that in Chile?
Offer a terse response. 0.35. What is the ratio of the Value added (current US$) of 1960 in Burkina Faso to that in China?
Your answer should be compact. 0.01. What is the ratio of the Value added (current US$) in 1961 in Burkina Faso to that in China?
Provide a short and direct response. 0.01. What is the ratio of the Value added (current US$) of 1962 in Burkina Faso to that in China?
Your answer should be compact. 0.01. What is the ratio of the Value added (current US$) of 1963 in Burkina Faso to that in China?
Ensure brevity in your answer.  0.01. What is the ratio of the Value added (current US$) in 1960 in Chad to that in Chile?
Give a very brief answer. 0.33. What is the ratio of the Value added (current US$) in 1961 in Chad to that in Chile?
Offer a terse response. 0.27. What is the ratio of the Value added (current US$) in 1962 in Chad to that in Chile?
Make the answer very short. 0.29. What is the ratio of the Value added (current US$) of 1963 in Chad to that in Chile?
Make the answer very short. 0.33. What is the ratio of the Value added (current US$) of 1960 in Chad to that in China?
Ensure brevity in your answer.  0.01. What is the ratio of the Value added (current US$) of 1961 in Chad to that in China?
Give a very brief answer. 0.01. What is the ratio of the Value added (current US$) in 1962 in Chad to that in China?
Make the answer very short. 0.01. What is the ratio of the Value added (current US$) of 1963 in Chad to that in China?
Make the answer very short. 0.01. What is the ratio of the Value added (current US$) in 1960 in Chile to that in China?
Ensure brevity in your answer.  0.03. What is the ratio of the Value added (current US$) in 1961 in Chile to that in China?
Give a very brief answer. 0.03. What is the ratio of the Value added (current US$) in 1962 in Chile to that in China?
Give a very brief answer. 0.03. What is the ratio of the Value added (current US$) in 1963 in Chile to that in China?
Provide a succinct answer. 0.02. What is the difference between the highest and the second highest Value added (current US$) in 1960?
Offer a terse response. 1.12e+1. What is the difference between the highest and the second highest Value added (current US$) of 1961?
Provide a short and direct response. 1.53e+1. What is the difference between the highest and the second highest Value added (current US$) of 1962?
Offer a terse response. 1.53e+1. What is the difference between the highest and the second highest Value added (current US$) of 1963?
Your answer should be very brief. 1.67e+1. What is the difference between the highest and the lowest Value added (current US$) in 1960?
Give a very brief answer. 1.38e+1. What is the difference between the highest and the lowest Value added (current US$) of 1961?
Provide a succinct answer. 1.79e+1. What is the difference between the highest and the lowest Value added (current US$) of 1962?
Ensure brevity in your answer.  1.84e+1. What is the difference between the highest and the lowest Value added (current US$) of 1963?
Your response must be concise. 2.02e+1. 